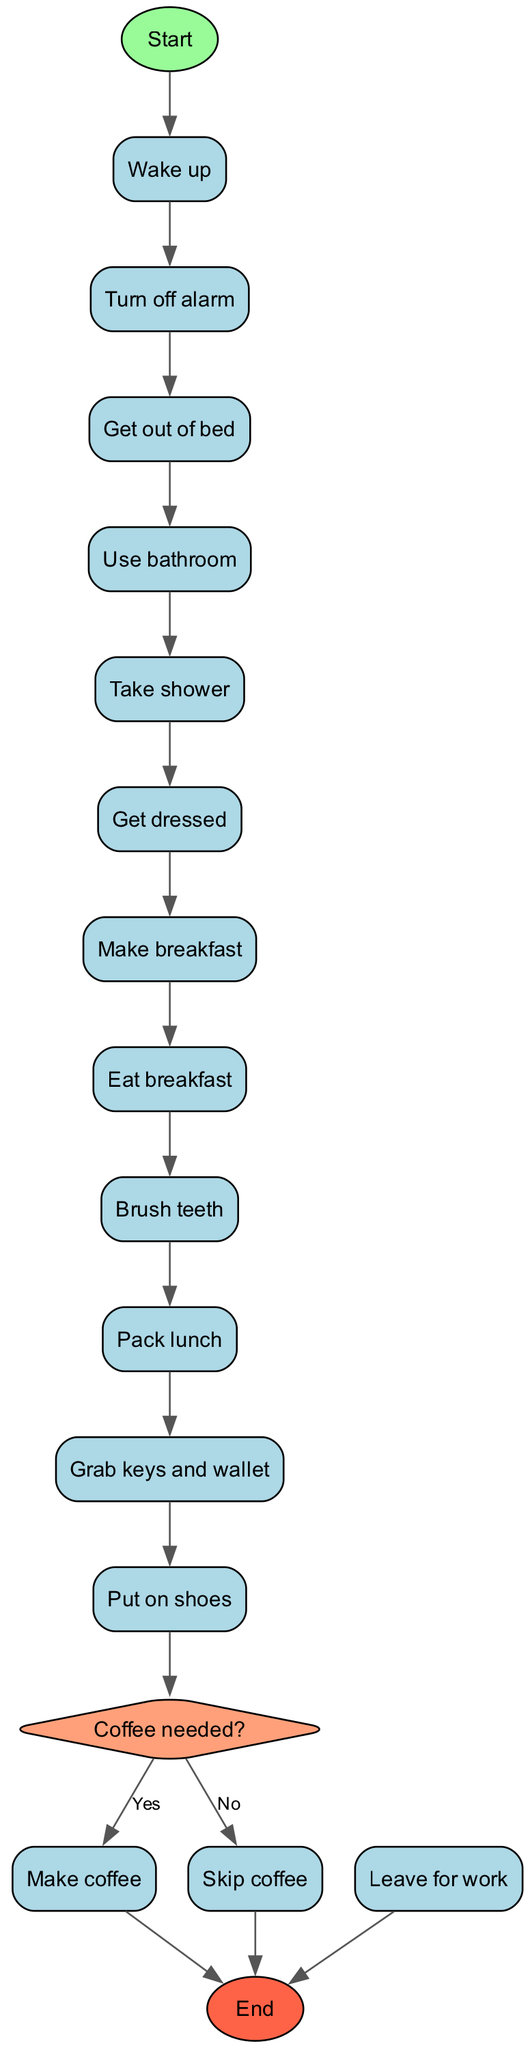What is the first activity in the morning routine? The first activity after waking up is indicated in the list of activities under the "activities" section. According to the diagram, it shows "Turn off alarm" as the first activity.
Answer: Turn off alarm How many activities are listed in the morning routine? By counting the entries in the "activities" section of the diagram, I see that there are 10 activities listed from "Turn off alarm" to "Pack lunch".
Answer: 10 What question is asked before making coffee? The decision made in the diagram before making coffee is presented as a question labeled "Coffee needed?" which is clearly shown in the decision node.
Answer: Coffee needed? What happens if the answer to the coffee question is "No"? According to the decision node in the diagram, if the answer is "No" to the coffee question, it indicates that the next step is to "Skip coffee" and then proceed towards the end of the routine.
Answer: Skip coffee What is the last activity before leaving for work? The last activity listed in the diagram before reaching the end node is "Put on shoes". This can be identified by looking at the sequential flow of activities leading up to the end.
Answer: Put on shoes How do you get to the end node after making coffee? To reach the end node after choosing to make coffee, the sequence follows: "Make coffee" leads back to the end of the routine without any additional steps shown after that. Thus, the flow directly continues to "Leave for work".
Answer: Leave for work What shape is used for the decision in the diagram? The shape used for the decision in this activity diagram is a diamond, which is standard for decision nodes to indicate branching based on a question or condition.
Answer: Diamond Which activity directly follows "Brush teeth"? The activity that comes right after "Brush teeth", according to the sequential flow in the diagram, is "Pack lunch". This is inferred by looking directly at the ordering of activities shown.
Answer: Pack lunch 